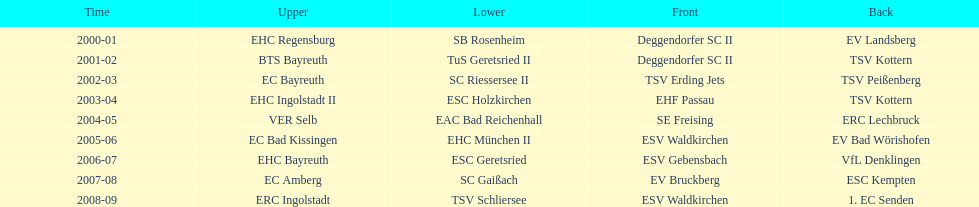What was the first club for the north in the 2000's? EHC Regensburg. 